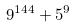Convert formula to latex. <formula><loc_0><loc_0><loc_500><loc_500>9 ^ { 1 4 4 } + 5 ^ { 9 }</formula> 